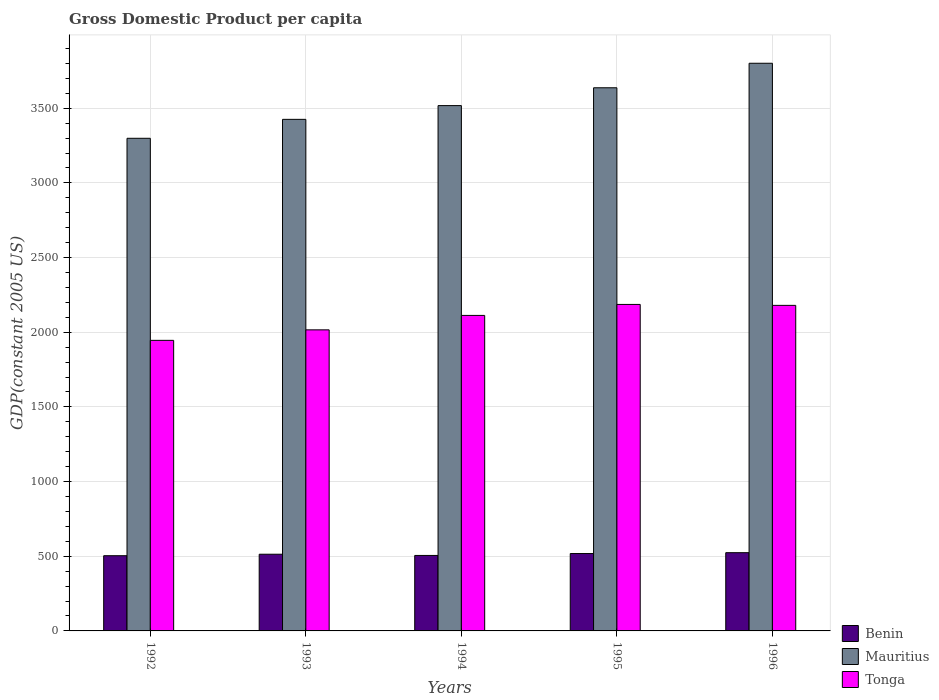How many groups of bars are there?
Give a very brief answer. 5. How many bars are there on the 5th tick from the left?
Your answer should be compact. 3. What is the label of the 2nd group of bars from the left?
Your response must be concise. 1993. What is the GDP per capita in Mauritius in 1992?
Offer a very short reply. 3298.81. Across all years, what is the maximum GDP per capita in Mauritius?
Provide a short and direct response. 3801.28. Across all years, what is the minimum GDP per capita in Benin?
Ensure brevity in your answer.  503.68. What is the total GDP per capita in Mauritius in the graph?
Make the answer very short. 1.77e+04. What is the difference between the GDP per capita in Mauritius in 1992 and that in 1993?
Your answer should be very brief. -126.79. What is the difference between the GDP per capita in Mauritius in 1993 and the GDP per capita in Benin in 1995?
Offer a very short reply. 2907.42. What is the average GDP per capita in Tonga per year?
Make the answer very short. 2088.19. In the year 1993, what is the difference between the GDP per capita in Benin and GDP per capita in Tonga?
Provide a short and direct response. -1502.53. What is the ratio of the GDP per capita in Benin in 1994 to that in 1995?
Provide a short and direct response. 0.98. Is the GDP per capita in Tonga in 1992 less than that in 1993?
Give a very brief answer. Yes. What is the difference between the highest and the second highest GDP per capita in Mauritius?
Provide a succinct answer. 164.16. What is the difference between the highest and the lowest GDP per capita in Mauritius?
Ensure brevity in your answer.  502.46. What does the 3rd bar from the left in 1993 represents?
Your answer should be very brief. Tonga. What does the 3rd bar from the right in 1992 represents?
Your answer should be compact. Benin. How many bars are there?
Offer a very short reply. 15. Are all the bars in the graph horizontal?
Offer a very short reply. No. Are the values on the major ticks of Y-axis written in scientific E-notation?
Keep it short and to the point. No. How are the legend labels stacked?
Your answer should be compact. Vertical. What is the title of the graph?
Ensure brevity in your answer.  Gross Domestic Product per capita. What is the label or title of the Y-axis?
Your answer should be very brief. GDP(constant 2005 US). What is the GDP(constant 2005 US) of Benin in 1992?
Provide a short and direct response. 503.68. What is the GDP(constant 2005 US) of Mauritius in 1992?
Provide a short and direct response. 3298.81. What is the GDP(constant 2005 US) of Tonga in 1992?
Provide a short and direct response. 1945.72. What is the GDP(constant 2005 US) of Benin in 1993?
Offer a terse response. 513.57. What is the GDP(constant 2005 US) in Mauritius in 1993?
Give a very brief answer. 3425.61. What is the GDP(constant 2005 US) in Tonga in 1993?
Give a very brief answer. 2016.11. What is the GDP(constant 2005 US) of Benin in 1994?
Offer a very short reply. 505.44. What is the GDP(constant 2005 US) of Mauritius in 1994?
Give a very brief answer. 3517.7. What is the GDP(constant 2005 US) in Tonga in 1994?
Keep it short and to the point. 2112.72. What is the GDP(constant 2005 US) in Benin in 1995?
Offer a very short reply. 518.19. What is the GDP(constant 2005 US) of Mauritius in 1995?
Give a very brief answer. 3637.12. What is the GDP(constant 2005 US) in Tonga in 1995?
Ensure brevity in your answer.  2186.32. What is the GDP(constant 2005 US) of Benin in 1996?
Keep it short and to the point. 523.91. What is the GDP(constant 2005 US) of Mauritius in 1996?
Give a very brief answer. 3801.28. What is the GDP(constant 2005 US) of Tonga in 1996?
Your answer should be compact. 2180.07. Across all years, what is the maximum GDP(constant 2005 US) of Benin?
Keep it short and to the point. 523.91. Across all years, what is the maximum GDP(constant 2005 US) in Mauritius?
Ensure brevity in your answer.  3801.28. Across all years, what is the maximum GDP(constant 2005 US) of Tonga?
Give a very brief answer. 2186.32. Across all years, what is the minimum GDP(constant 2005 US) of Benin?
Ensure brevity in your answer.  503.68. Across all years, what is the minimum GDP(constant 2005 US) of Mauritius?
Provide a succinct answer. 3298.81. Across all years, what is the minimum GDP(constant 2005 US) in Tonga?
Keep it short and to the point. 1945.72. What is the total GDP(constant 2005 US) of Benin in the graph?
Your response must be concise. 2564.79. What is the total GDP(constant 2005 US) of Mauritius in the graph?
Provide a short and direct response. 1.77e+04. What is the total GDP(constant 2005 US) of Tonga in the graph?
Offer a very short reply. 1.04e+04. What is the difference between the GDP(constant 2005 US) in Benin in 1992 and that in 1993?
Your answer should be compact. -9.9. What is the difference between the GDP(constant 2005 US) in Mauritius in 1992 and that in 1993?
Ensure brevity in your answer.  -126.79. What is the difference between the GDP(constant 2005 US) of Tonga in 1992 and that in 1993?
Make the answer very short. -70.39. What is the difference between the GDP(constant 2005 US) of Benin in 1992 and that in 1994?
Offer a terse response. -1.77. What is the difference between the GDP(constant 2005 US) of Mauritius in 1992 and that in 1994?
Keep it short and to the point. -218.89. What is the difference between the GDP(constant 2005 US) in Tonga in 1992 and that in 1994?
Offer a terse response. -167.01. What is the difference between the GDP(constant 2005 US) in Benin in 1992 and that in 1995?
Your answer should be very brief. -14.52. What is the difference between the GDP(constant 2005 US) in Mauritius in 1992 and that in 1995?
Your answer should be very brief. -338.3. What is the difference between the GDP(constant 2005 US) of Tonga in 1992 and that in 1995?
Provide a short and direct response. -240.61. What is the difference between the GDP(constant 2005 US) of Benin in 1992 and that in 1996?
Offer a very short reply. -20.24. What is the difference between the GDP(constant 2005 US) in Mauritius in 1992 and that in 1996?
Your response must be concise. -502.46. What is the difference between the GDP(constant 2005 US) of Tonga in 1992 and that in 1996?
Make the answer very short. -234.35. What is the difference between the GDP(constant 2005 US) of Benin in 1993 and that in 1994?
Keep it short and to the point. 8.13. What is the difference between the GDP(constant 2005 US) in Mauritius in 1993 and that in 1994?
Make the answer very short. -92.09. What is the difference between the GDP(constant 2005 US) in Tonga in 1993 and that in 1994?
Offer a terse response. -96.62. What is the difference between the GDP(constant 2005 US) in Benin in 1993 and that in 1995?
Keep it short and to the point. -4.62. What is the difference between the GDP(constant 2005 US) in Mauritius in 1993 and that in 1995?
Your response must be concise. -211.51. What is the difference between the GDP(constant 2005 US) of Tonga in 1993 and that in 1995?
Give a very brief answer. -170.22. What is the difference between the GDP(constant 2005 US) of Benin in 1993 and that in 1996?
Make the answer very short. -10.34. What is the difference between the GDP(constant 2005 US) of Mauritius in 1993 and that in 1996?
Offer a very short reply. -375.67. What is the difference between the GDP(constant 2005 US) of Tonga in 1993 and that in 1996?
Ensure brevity in your answer.  -163.96. What is the difference between the GDP(constant 2005 US) in Benin in 1994 and that in 1995?
Your answer should be very brief. -12.75. What is the difference between the GDP(constant 2005 US) of Mauritius in 1994 and that in 1995?
Provide a succinct answer. -119.42. What is the difference between the GDP(constant 2005 US) of Tonga in 1994 and that in 1995?
Provide a succinct answer. -73.6. What is the difference between the GDP(constant 2005 US) of Benin in 1994 and that in 1996?
Your answer should be very brief. -18.47. What is the difference between the GDP(constant 2005 US) in Mauritius in 1994 and that in 1996?
Provide a succinct answer. -283.58. What is the difference between the GDP(constant 2005 US) of Tonga in 1994 and that in 1996?
Provide a short and direct response. -67.34. What is the difference between the GDP(constant 2005 US) in Benin in 1995 and that in 1996?
Keep it short and to the point. -5.72. What is the difference between the GDP(constant 2005 US) of Mauritius in 1995 and that in 1996?
Offer a very short reply. -164.16. What is the difference between the GDP(constant 2005 US) in Tonga in 1995 and that in 1996?
Offer a very short reply. 6.26. What is the difference between the GDP(constant 2005 US) in Benin in 1992 and the GDP(constant 2005 US) in Mauritius in 1993?
Your answer should be very brief. -2921.93. What is the difference between the GDP(constant 2005 US) in Benin in 1992 and the GDP(constant 2005 US) in Tonga in 1993?
Give a very brief answer. -1512.43. What is the difference between the GDP(constant 2005 US) in Mauritius in 1992 and the GDP(constant 2005 US) in Tonga in 1993?
Offer a terse response. 1282.71. What is the difference between the GDP(constant 2005 US) of Benin in 1992 and the GDP(constant 2005 US) of Mauritius in 1994?
Ensure brevity in your answer.  -3014.02. What is the difference between the GDP(constant 2005 US) in Benin in 1992 and the GDP(constant 2005 US) in Tonga in 1994?
Provide a short and direct response. -1609.05. What is the difference between the GDP(constant 2005 US) in Mauritius in 1992 and the GDP(constant 2005 US) in Tonga in 1994?
Give a very brief answer. 1186.09. What is the difference between the GDP(constant 2005 US) of Benin in 1992 and the GDP(constant 2005 US) of Mauritius in 1995?
Your answer should be very brief. -3133.44. What is the difference between the GDP(constant 2005 US) of Benin in 1992 and the GDP(constant 2005 US) of Tonga in 1995?
Provide a succinct answer. -1682.65. What is the difference between the GDP(constant 2005 US) in Mauritius in 1992 and the GDP(constant 2005 US) in Tonga in 1995?
Offer a very short reply. 1112.49. What is the difference between the GDP(constant 2005 US) in Benin in 1992 and the GDP(constant 2005 US) in Mauritius in 1996?
Give a very brief answer. -3297.6. What is the difference between the GDP(constant 2005 US) in Benin in 1992 and the GDP(constant 2005 US) in Tonga in 1996?
Ensure brevity in your answer.  -1676.39. What is the difference between the GDP(constant 2005 US) of Mauritius in 1992 and the GDP(constant 2005 US) of Tonga in 1996?
Provide a succinct answer. 1118.74. What is the difference between the GDP(constant 2005 US) in Benin in 1993 and the GDP(constant 2005 US) in Mauritius in 1994?
Ensure brevity in your answer.  -3004.13. What is the difference between the GDP(constant 2005 US) in Benin in 1993 and the GDP(constant 2005 US) in Tonga in 1994?
Provide a short and direct response. -1599.15. What is the difference between the GDP(constant 2005 US) of Mauritius in 1993 and the GDP(constant 2005 US) of Tonga in 1994?
Keep it short and to the point. 1312.88. What is the difference between the GDP(constant 2005 US) in Benin in 1993 and the GDP(constant 2005 US) in Mauritius in 1995?
Provide a short and direct response. -3123.55. What is the difference between the GDP(constant 2005 US) of Benin in 1993 and the GDP(constant 2005 US) of Tonga in 1995?
Your response must be concise. -1672.75. What is the difference between the GDP(constant 2005 US) in Mauritius in 1993 and the GDP(constant 2005 US) in Tonga in 1995?
Ensure brevity in your answer.  1239.28. What is the difference between the GDP(constant 2005 US) in Benin in 1993 and the GDP(constant 2005 US) in Mauritius in 1996?
Provide a succinct answer. -3287.7. What is the difference between the GDP(constant 2005 US) of Benin in 1993 and the GDP(constant 2005 US) of Tonga in 1996?
Your response must be concise. -1666.5. What is the difference between the GDP(constant 2005 US) in Mauritius in 1993 and the GDP(constant 2005 US) in Tonga in 1996?
Your answer should be very brief. 1245.54. What is the difference between the GDP(constant 2005 US) of Benin in 1994 and the GDP(constant 2005 US) of Mauritius in 1995?
Provide a short and direct response. -3131.67. What is the difference between the GDP(constant 2005 US) of Benin in 1994 and the GDP(constant 2005 US) of Tonga in 1995?
Provide a succinct answer. -1680.88. What is the difference between the GDP(constant 2005 US) of Mauritius in 1994 and the GDP(constant 2005 US) of Tonga in 1995?
Make the answer very short. 1331.37. What is the difference between the GDP(constant 2005 US) of Benin in 1994 and the GDP(constant 2005 US) of Mauritius in 1996?
Make the answer very short. -3295.83. What is the difference between the GDP(constant 2005 US) of Benin in 1994 and the GDP(constant 2005 US) of Tonga in 1996?
Provide a short and direct response. -1674.62. What is the difference between the GDP(constant 2005 US) of Mauritius in 1994 and the GDP(constant 2005 US) of Tonga in 1996?
Ensure brevity in your answer.  1337.63. What is the difference between the GDP(constant 2005 US) of Benin in 1995 and the GDP(constant 2005 US) of Mauritius in 1996?
Offer a very short reply. -3283.09. What is the difference between the GDP(constant 2005 US) in Benin in 1995 and the GDP(constant 2005 US) in Tonga in 1996?
Keep it short and to the point. -1661.88. What is the difference between the GDP(constant 2005 US) in Mauritius in 1995 and the GDP(constant 2005 US) in Tonga in 1996?
Offer a terse response. 1457.05. What is the average GDP(constant 2005 US) of Benin per year?
Offer a terse response. 512.96. What is the average GDP(constant 2005 US) of Mauritius per year?
Keep it short and to the point. 3536.1. What is the average GDP(constant 2005 US) in Tonga per year?
Keep it short and to the point. 2088.19. In the year 1992, what is the difference between the GDP(constant 2005 US) of Benin and GDP(constant 2005 US) of Mauritius?
Your answer should be compact. -2795.14. In the year 1992, what is the difference between the GDP(constant 2005 US) of Benin and GDP(constant 2005 US) of Tonga?
Your answer should be very brief. -1442.04. In the year 1992, what is the difference between the GDP(constant 2005 US) of Mauritius and GDP(constant 2005 US) of Tonga?
Offer a terse response. 1353.09. In the year 1993, what is the difference between the GDP(constant 2005 US) in Benin and GDP(constant 2005 US) in Mauritius?
Provide a succinct answer. -2912.04. In the year 1993, what is the difference between the GDP(constant 2005 US) in Benin and GDP(constant 2005 US) in Tonga?
Keep it short and to the point. -1502.53. In the year 1993, what is the difference between the GDP(constant 2005 US) in Mauritius and GDP(constant 2005 US) in Tonga?
Keep it short and to the point. 1409.5. In the year 1994, what is the difference between the GDP(constant 2005 US) of Benin and GDP(constant 2005 US) of Mauritius?
Your answer should be very brief. -3012.26. In the year 1994, what is the difference between the GDP(constant 2005 US) in Benin and GDP(constant 2005 US) in Tonga?
Make the answer very short. -1607.28. In the year 1994, what is the difference between the GDP(constant 2005 US) of Mauritius and GDP(constant 2005 US) of Tonga?
Offer a very short reply. 1404.97. In the year 1995, what is the difference between the GDP(constant 2005 US) of Benin and GDP(constant 2005 US) of Mauritius?
Keep it short and to the point. -3118.93. In the year 1995, what is the difference between the GDP(constant 2005 US) in Benin and GDP(constant 2005 US) in Tonga?
Make the answer very short. -1668.13. In the year 1995, what is the difference between the GDP(constant 2005 US) of Mauritius and GDP(constant 2005 US) of Tonga?
Offer a terse response. 1450.79. In the year 1996, what is the difference between the GDP(constant 2005 US) in Benin and GDP(constant 2005 US) in Mauritius?
Your answer should be compact. -3277.36. In the year 1996, what is the difference between the GDP(constant 2005 US) in Benin and GDP(constant 2005 US) in Tonga?
Offer a very short reply. -1656.16. In the year 1996, what is the difference between the GDP(constant 2005 US) in Mauritius and GDP(constant 2005 US) in Tonga?
Give a very brief answer. 1621.21. What is the ratio of the GDP(constant 2005 US) of Benin in 1992 to that in 1993?
Give a very brief answer. 0.98. What is the ratio of the GDP(constant 2005 US) in Tonga in 1992 to that in 1993?
Your response must be concise. 0.97. What is the ratio of the GDP(constant 2005 US) in Mauritius in 1992 to that in 1994?
Offer a very short reply. 0.94. What is the ratio of the GDP(constant 2005 US) of Tonga in 1992 to that in 1994?
Provide a succinct answer. 0.92. What is the ratio of the GDP(constant 2005 US) in Mauritius in 1992 to that in 1995?
Provide a short and direct response. 0.91. What is the ratio of the GDP(constant 2005 US) in Tonga in 1992 to that in 1995?
Your response must be concise. 0.89. What is the ratio of the GDP(constant 2005 US) in Benin in 1992 to that in 1996?
Your answer should be very brief. 0.96. What is the ratio of the GDP(constant 2005 US) of Mauritius in 1992 to that in 1996?
Ensure brevity in your answer.  0.87. What is the ratio of the GDP(constant 2005 US) of Tonga in 1992 to that in 1996?
Keep it short and to the point. 0.89. What is the ratio of the GDP(constant 2005 US) of Benin in 1993 to that in 1994?
Your answer should be very brief. 1.02. What is the ratio of the GDP(constant 2005 US) in Mauritius in 1993 to that in 1994?
Make the answer very short. 0.97. What is the ratio of the GDP(constant 2005 US) of Tonga in 1993 to that in 1994?
Offer a very short reply. 0.95. What is the ratio of the GDP(constant 2005 US) of Benin in 1993 to that in 1995?
Make the answer very short. 0.99. What is the ratio of the GDP(constant 2005 US) of Mauritius in 1993 to that in 1995?
Your answer should be very brief. 0.94. What is the ratio of the GDP(constant 2005 US) in Tonga in 1993 to that in 1995?
Your response must be concise. 0.92. What is the ratio of the GDP(constant 2005 US) of Benin in 1993 to that in 1996?
Provide a succinct answer. 0.98. What is the ratio of the GDP(constant 2005 US) of Mauritius in 1993 to that in 1996?
Provide a short and direct response. 0.9. What is the ratio of the GDP(constant 2005 US) in Tonga in 1993 to that in 1996?
Ensure brevity in your answer.  0.92. What is the ratio of the GDP(constant 2005 US) in Benin in 1994 to that in 1995?
Offer a terse response. 0.98. What is the ratio of the GDP(constant 2005 US) in Mauritius in 1994 to that in 1995?
Keep it short and to the point. 0.97. What is the ratio of the GDP(constant 2005 US) in Tonga in 1994 to that in 1995?
Offer a very short reply. 0.97. What is the ratio of the GDP(constant 2005 US) of Benin in 1994 to that in 1996?
Your answer should be compact. 0.96. What is the ratio of the GDP(constant 2005 US) of Mauritius in 1994 to that in 1996?
Provide a short and direct response. 0.93. What is the ratio of the GDP(constant 2005 US) of Tonga in 1994 to that in 1996?
Keep it short and to the point. 0.97. What is the ratio of the GDP(constant 2005 US) of Mauritius in 1995 to that in 1996?
Make the answer very short. 0.96. What is the ratio of the GDP(constant 2005 US) in Tonga in 1995 to that in 1996?
Your answer should be compact. 1. What is the difference between the highest and the second highest GDP(constant 2005 US) of Benin?
Your response must be concise. 5.72. What is the difference between the highest and the second highest GDP(constant 2005 US) of Mauritius?
Offer a very short reply. 164.16. What is the difference between the highest and the second highest GDP(constant 2005 US) of Tonga?
Your answer should be compact. 6.26. What is the difference between the highest and the lowest GDP(constant 2005 US) of Benin?
Your answer should be very brief. 20.24. What is the difference between the highest and the lowest GDP(constant 2005 US) in Mauritius?
Make the answer very short. 502.46. What is the difference between the highest and the lowest GDP(constant 2005 US) in Tonga?
Provide a short and direct response. 240.61. 